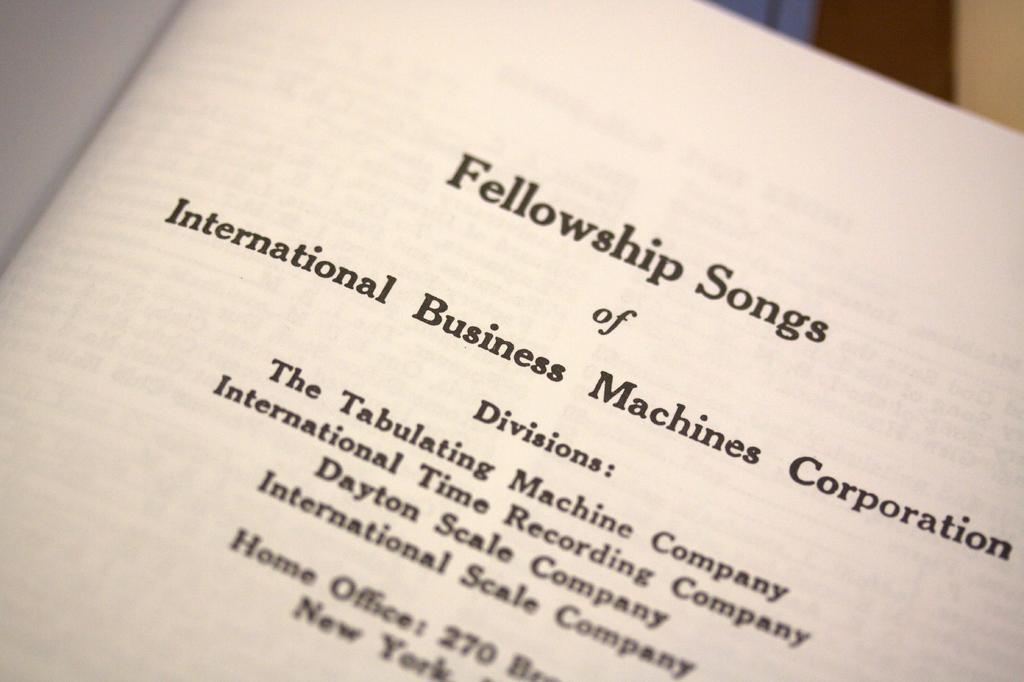Can you describe this image briefly? Something written on this paper. Background it is blur. 